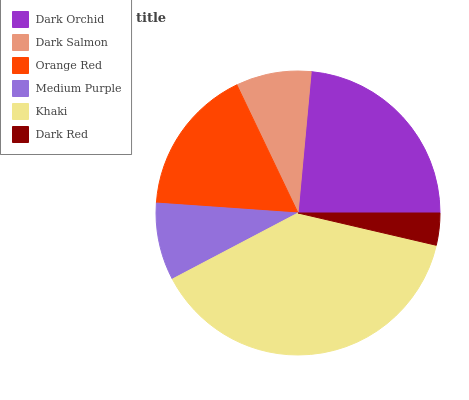Is Dark Red the minimum?
Answer yes or no. Yes. Is Khaki the maximum?
Answer yes or no. Yes. Is Dark Salmon the minimum?
Answer yes or no. No. Is Dark Salmon the maximum?
Answer yes or no. No. Is Dark Orchid greater than Dark Salmon?
Answer yes or no. Yes. Is Dark Salmon less than Dark Orchid?
Answer yes or no. Yes. Is Dark Salmon greater than Dark Orchid?
Answer yes or no. No. Is Dark Orchid less than Dark Salmon?
Answer yes or no. No. Is Orange Red the high median?
Answer yes or no. Yes. Is Medium Purple the low median?
Answer yes or no. Yes. Is Dark Salmon the high median?
Answer yes or no. No. Is Khaki the low median?
Answer yes or no. No. 